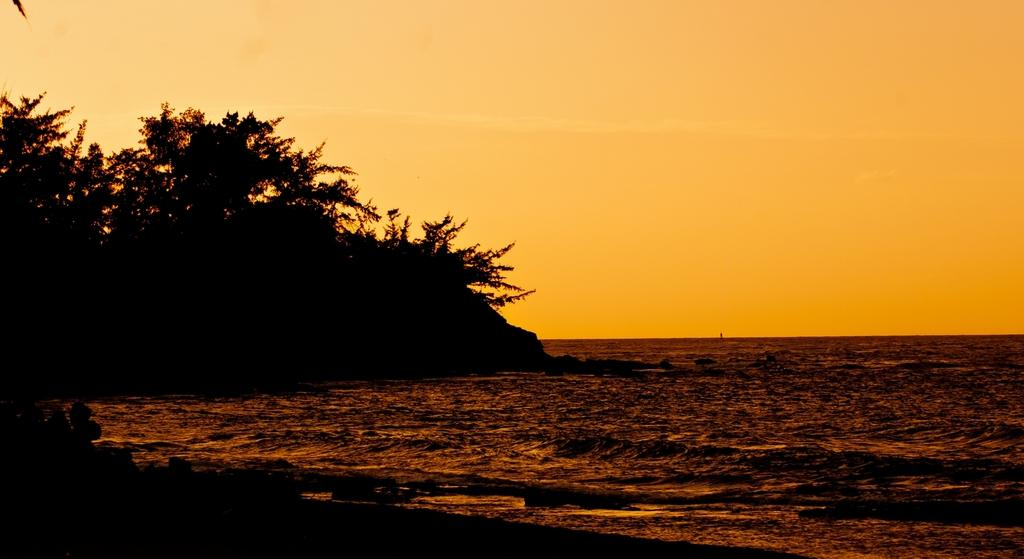What type of landscape is depicted on the left side of the image? There are many trees on the mountain on the left side of the image. What type of body of water is visible on the right side of the image? There is an ocean visible on the right side of the image. What is visible at the top of the image? The sky is visible at the top of the image. What can be seen in the sky in the image? Clouds are present in the sky. What type of instrument is being played by the bear on the coast in the image? There are no bears or instruments present in the image. What type of coast can be seen in the image? The image does not depict a coast; it shows a mountain with trees on the left and an ocean on the right. 